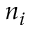Convert formula to latex. <formula><loc_0><loc_0><loc_500><loc_500>n _ { i }</formula> 